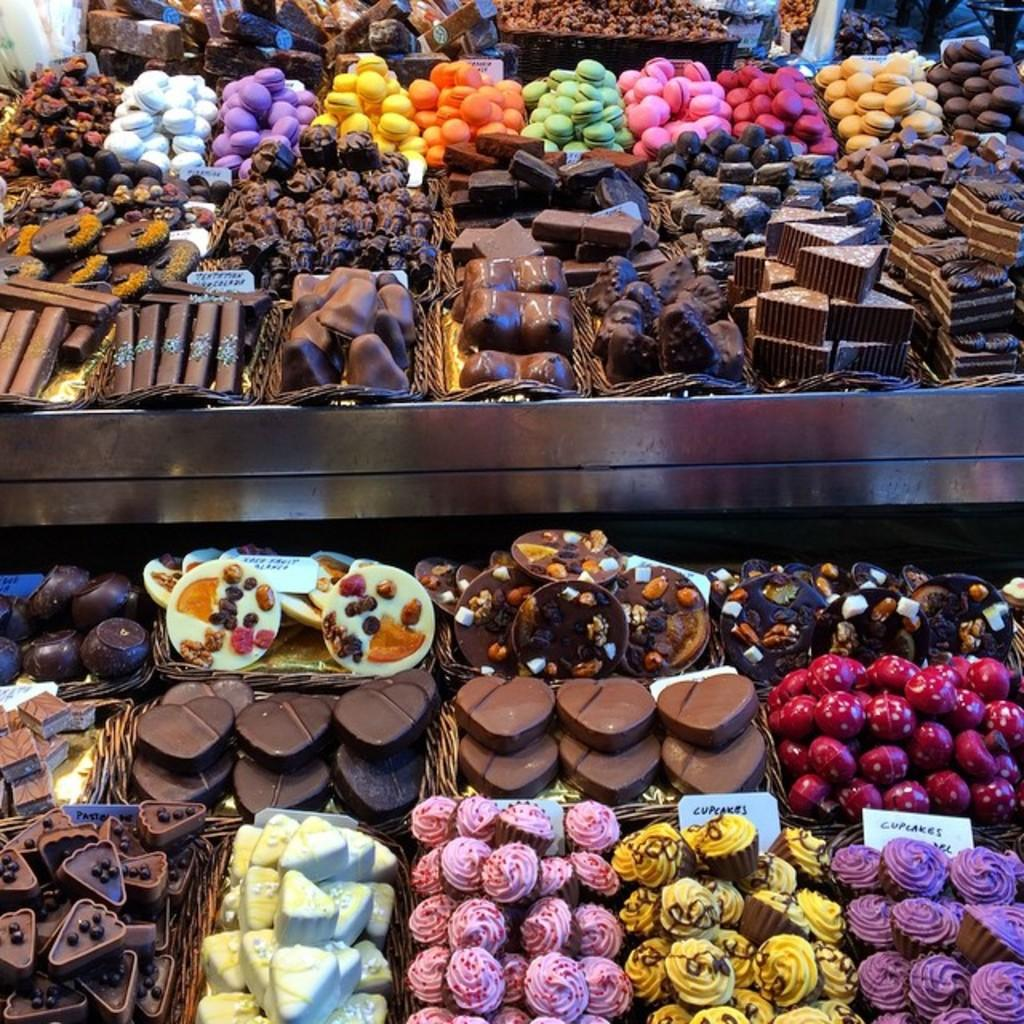What type of food can be seen in the image? There are cookies in the image. How many different colors can be observed on the cookies? The cookies are in different colors. How are the cookies arranged in the image? The cookies are arranged in baskets. Where are the baskets located in the image? The baskets are on shelves. Can you see any passengers near the lake in the image? There is no reference to passengers or a lake in the image; it features cookies arranged in baskets on shelves. 